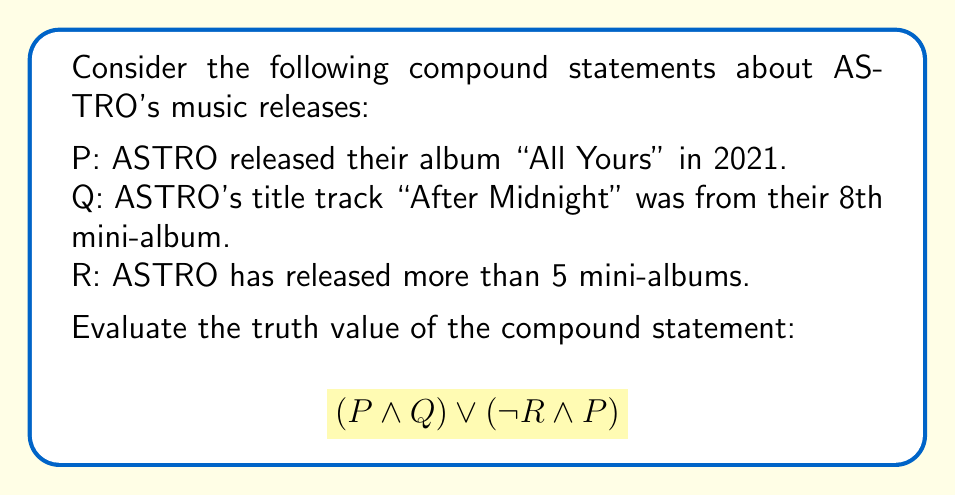Give your solution to this math problem. To evaluate the truth value of this compound statement, we need to break it down into its components and determine their individual truth values:

1. P: ASTRO released their album "All Yours" in 2021.
   This is true. ASTRO released "All Yours" on April 5, 2021.

2. Q: ASTRO's title track "After Midnight" was from their 8th mini-album.
   This is false. "After Midnight" was the title track of their 9th mini-album "Drive to the Starry Road" released in 2022.

3. R: ASTRO has released more than 5 mini-albums.
   This is true. As of 2023, ASTRO has released 9 mini-albums.

Now, let's evaluate the compound statement step by step:

1. $(P \land Q)$:
   P is true, Q is false
   True AND False = False

2. $(\neg R \land P)$:
   $\neg R$ is false (since R is true), P is true
   False AND True = False

3. $(P \land Q) \lor (\neg R \land P)$:
   False OR False = False

Therefore, the entire compound statement evaluates to False.
Answer: False 